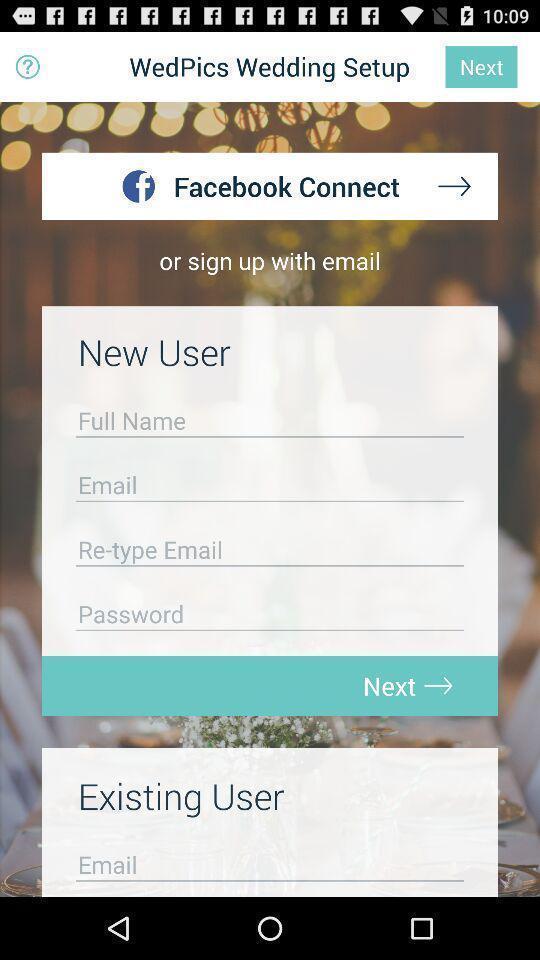Summarize the main components in this picture. Sign up page. 